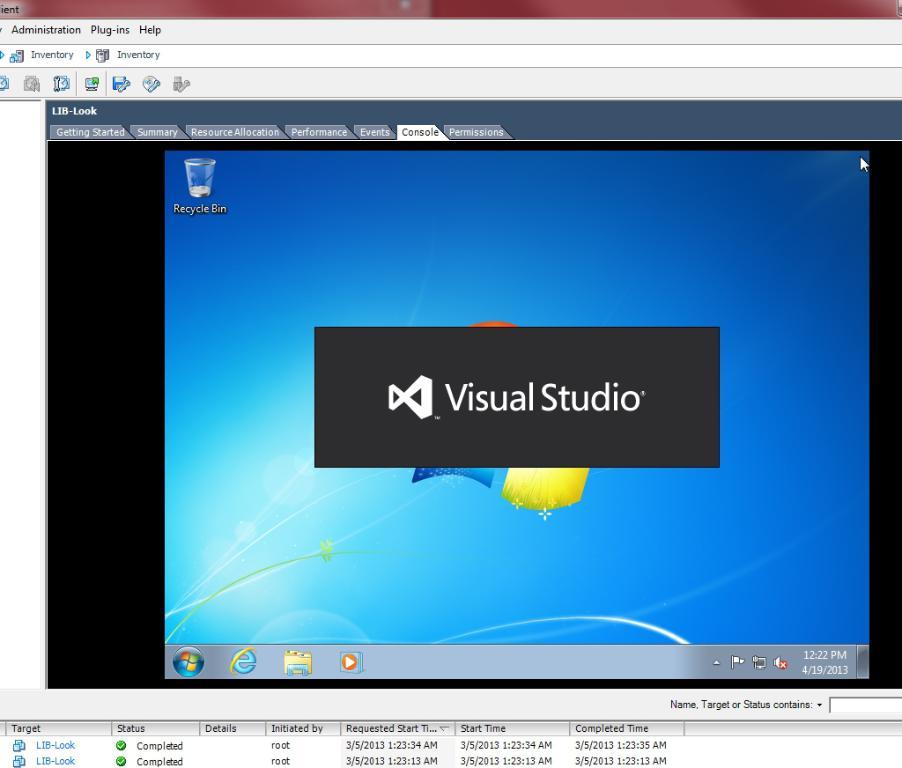<image>
Relay a brief, clear account of the picture shown. A Microsoft Windows computer screen displaying the words "Visual Studio" 